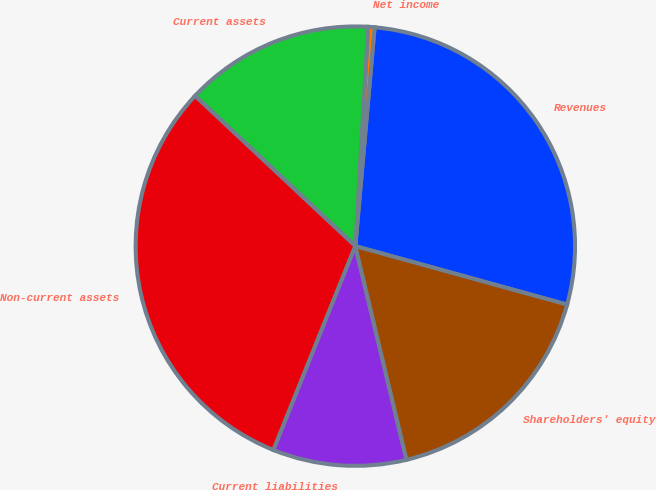Convert chart to OTSL. <chart><loc_0><loc_0><loc_500><loc_500><pie_chart><fcel>Revenues<fcel>Net income<fcel>Current assets<fcel>Non-current assets<fcel>Current liabilities<fcel>Shareholders' equity<nl><fcel>27.89%<fcel>0.47%<fcel>13.94%<fcel>30.91%<fcel>9.82%<fcel>16.97%<nl></chart> 